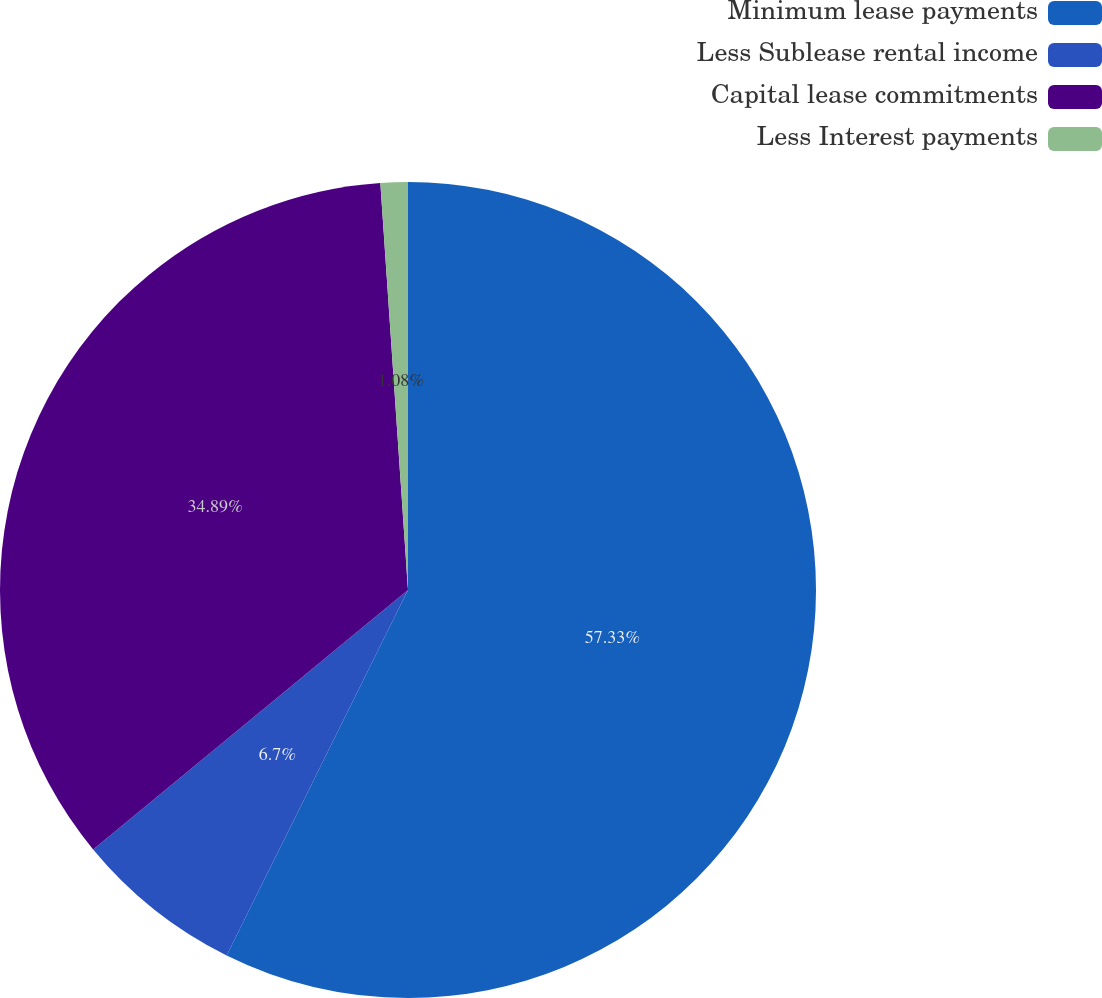Convert chart. <chart><loc_0><loc_0><loc_500><loc_500><pie_chart><fcel>Minimum lease payments<fcel>Less Sublease rental income<fcel>Capital lease commitments<fcel>Less Interest payments<nl><fcel>57.33%<fcel>6.7%<fcel>34.89%<fcel>1.08%<nl></chart> 